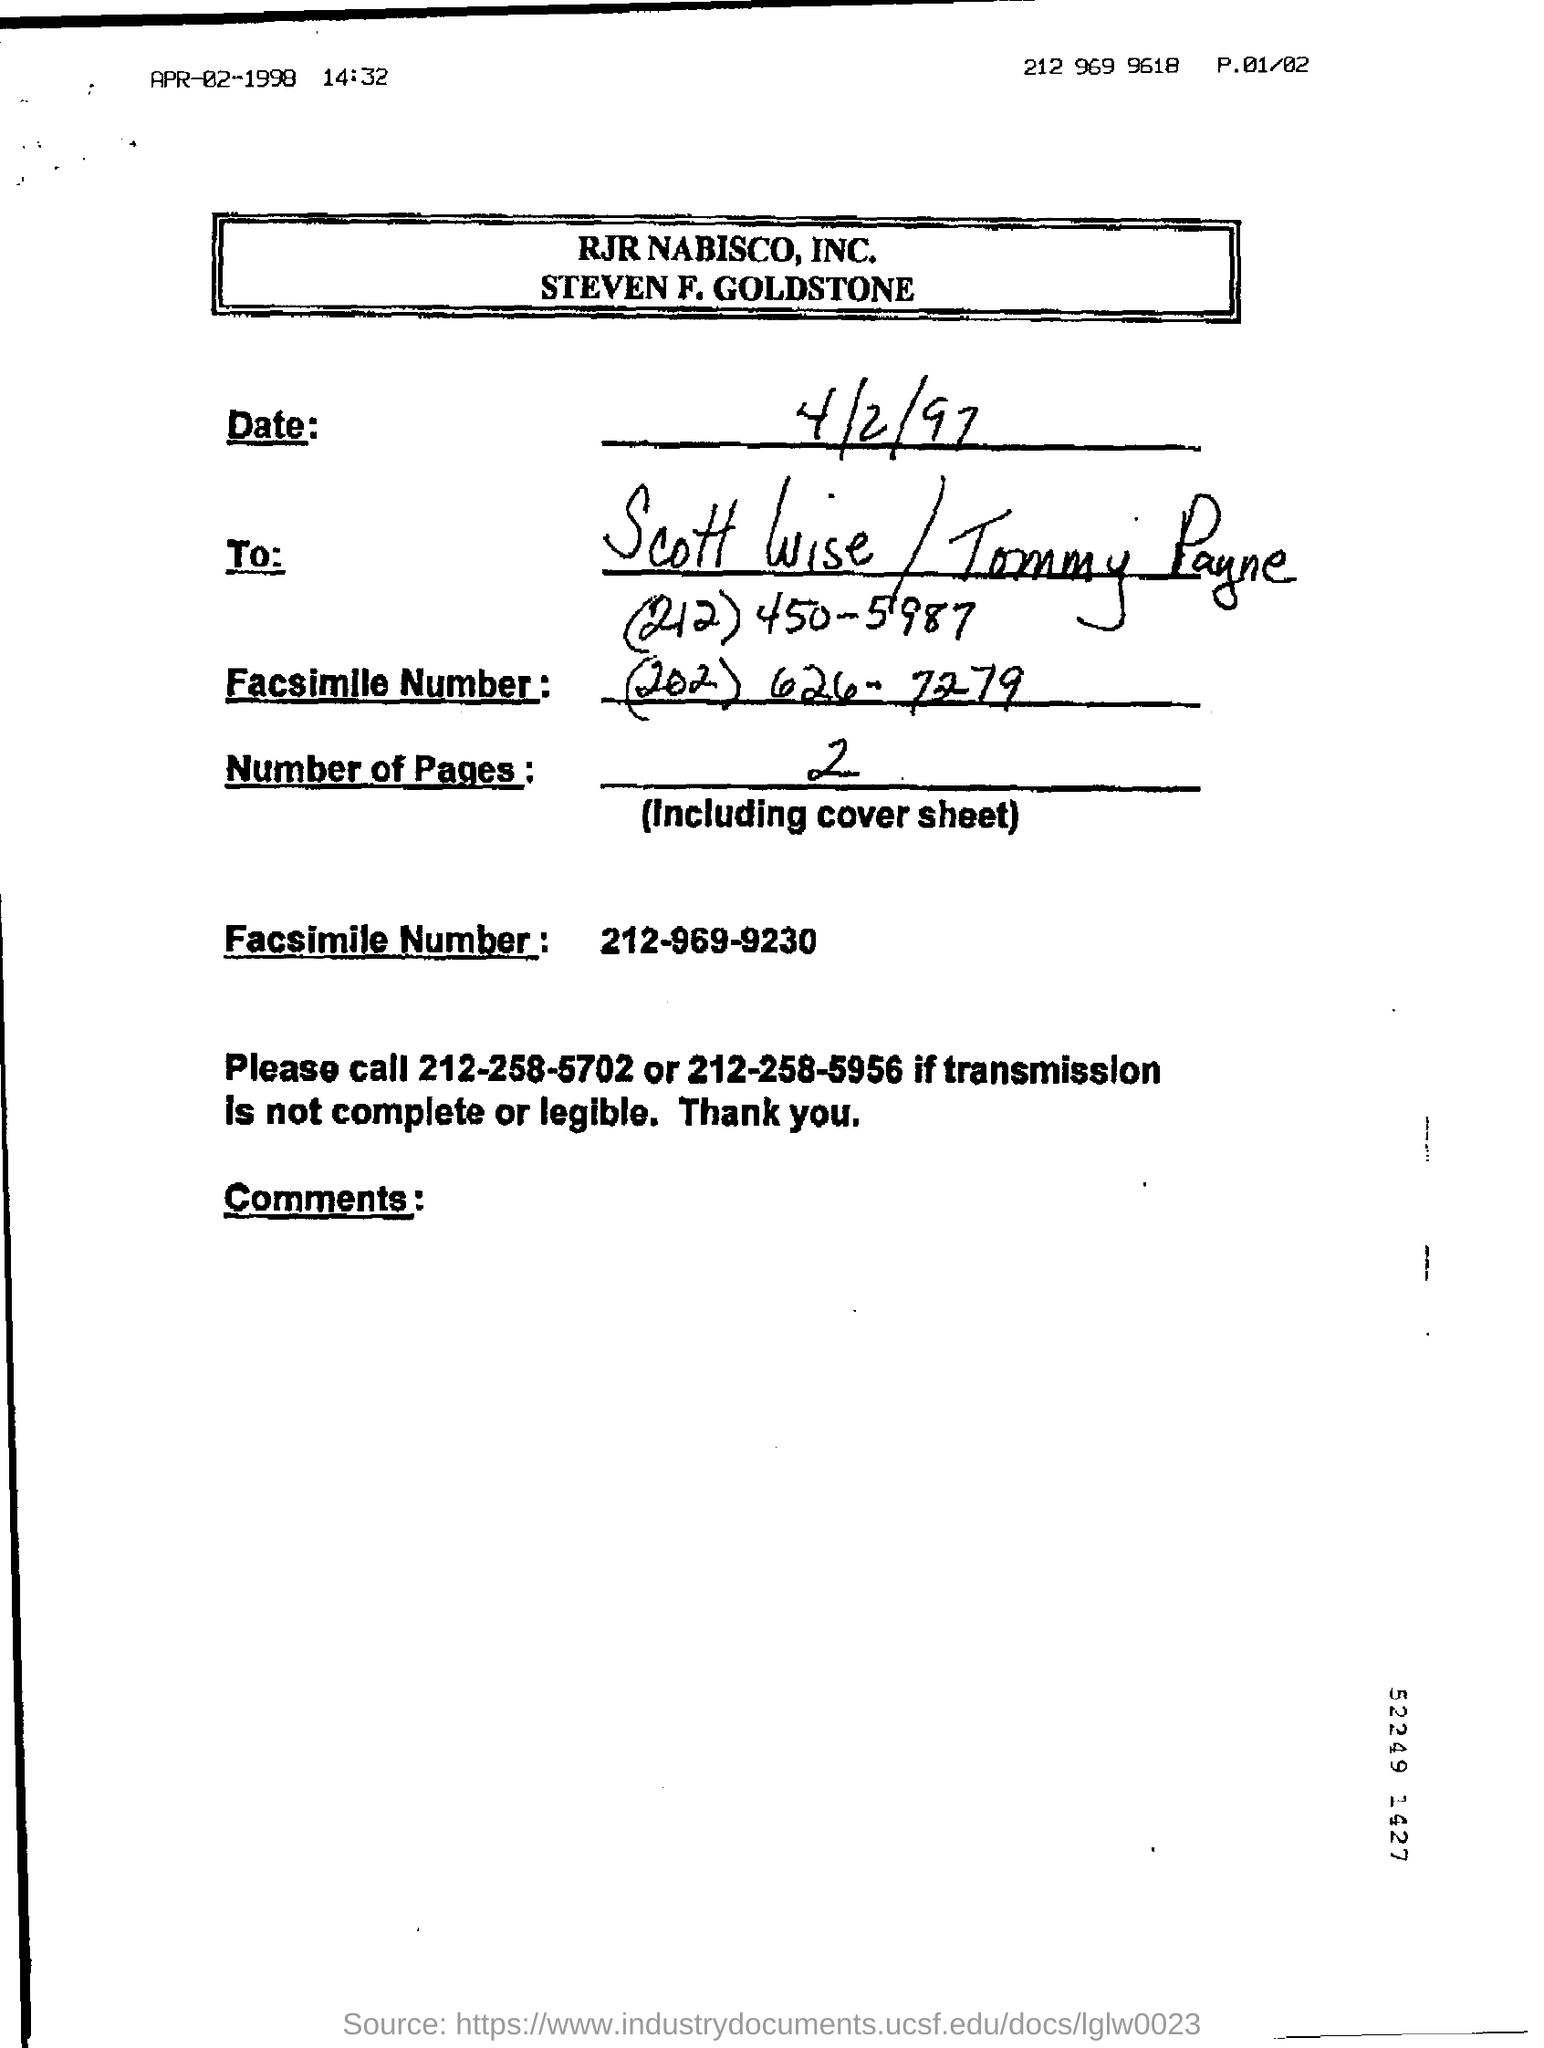Give some essential details in this illustration. The number of pages is two. The number of pages in the fax, including the cover page, is two. The date mentioned is April 2, 1997. 